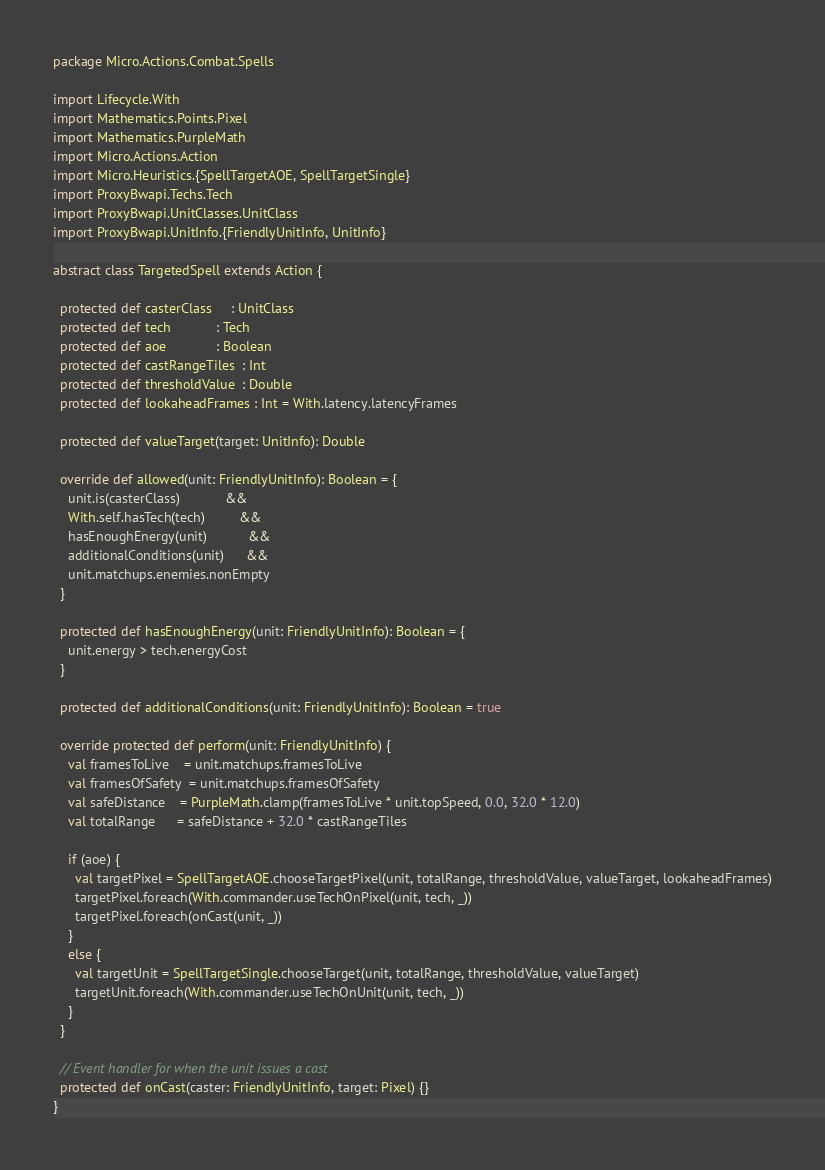<code> <loc_0><loc_0><loc_500><loc_500><_Scala_>package Micro.Actions.Combat.Spells

import Lifecycle.With
import Mathematics.Points.Pixel
import Mathematics.PurpleMath
import Micro.Actions.Action
import Micro.Heuristics.{SpellTargetAOE, SpellTargetSingle}
import ProxyBwapi.Techs.Tech
import ProxyBwapi.UnitClasses.UnitClass
import ProxyBwapi.UnitInfo.{FriendlyUnitInfo, UnitInfo}

abstract class TargetedSpell extends Action {
  
  protected def casterClass     : UnitClass
  protected def tech            : Tech
  protected def aoe             : Boolean
  protected def castRangeTiles  : Int
  protected def thresholdValue  : Double
  protected def lookaheadFrames : Int = With.latency.latencyFrames
  
  protected def valueTarget(target: UnitInfo): Double
  
  override def allowed(unit: FriendlyUnitInfo): Boolean = {
    unit.is(casterClass)            &&
    With.self.hasTech(tech)         &&
    hasEnoughEnergy(unit)           &&
    additionalConditions(unit)      &&
    unit.matchups.enemies.nonEmpty
  }
  
  protected def hasEnoughEnergy(unit: FriendlyUnitInfo): Boolean = {
    unit.energy > tech.energyCost
  }
  
  protected def additionalConditions(unit: FriendlyUnitInfo): Boolean = true
  
  override protected def perform(unit: FriendlyUnitInfo) {
    val framesToLive    = unit.matchups.framesToLive
    val framesOfSafety  = unit.matchups.framesOfSafety
    val safeDistance    = PurpleMath.clamp(framesToLive * unit.topSpeed, 0.0, 32.0 * 12.0)
    val totalRange      = safeDistance + 32.0 * castRangeTiles
    
    if (aoe) {
      val targetPixel = SpellTargetAOE.chooseTargetPixel(unit, totalRange, thresholdValue, valueTarget, lookaheadFrames)
      targetPixel.foreach(With.commander.useTechOnPixel(unit, tech, _))
      targetPixel.foreach(onCast(unit, _))
    }
    else {
      val targetUnit = SpellTargetSingle.chooseTarget(unit, totalRange, thresholdValue, valueTarget)
      targetUnit.foreach(With.commander.useTechOnUnit(unit, tech, _))
    }
  }
  
  // Event handler for when the unit issues a cast
  protected def onCast(caster: FriendlyUnitInfo, target: Pixel) {}
}
</code> 